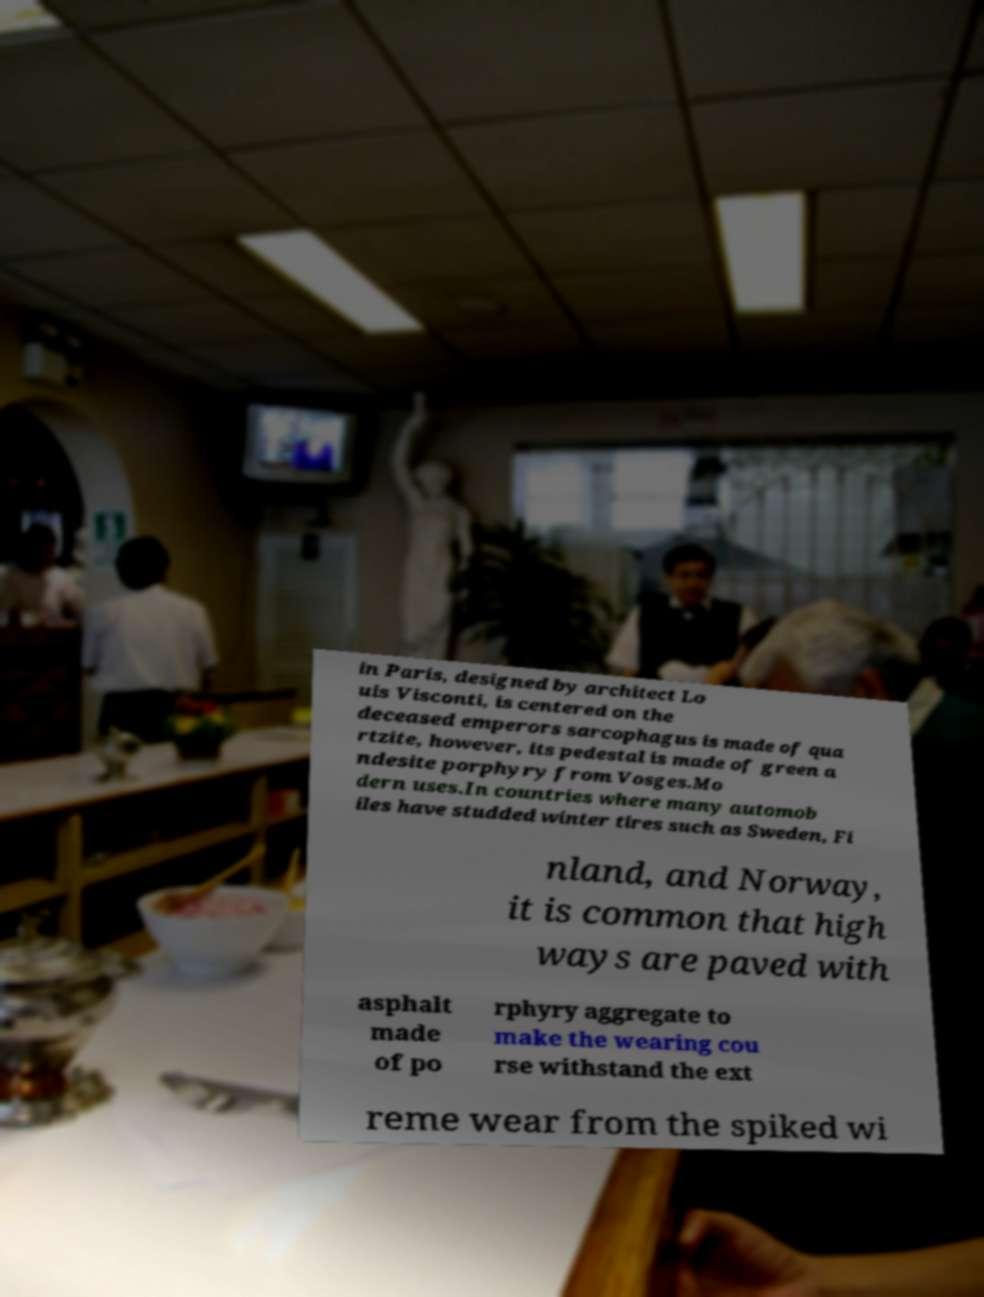I need the written content from this picture converted into text. Can you do that? in Paris, designed by architect Lo uis Visconti, is centered on the deceased emperors sarcophagus is made of qua rtzite, however, its pedestal is made of green a ndesite porphyry from Vosges.Mo dern uses.In countries where many automob iles have studded winter tires such as Sweden, Fi nland, and Norway, it is common that high ways are paved with asphalt made of po rphyry aggregate to make the wearing cou rse withstand the ext reme wear from the spiked wi 